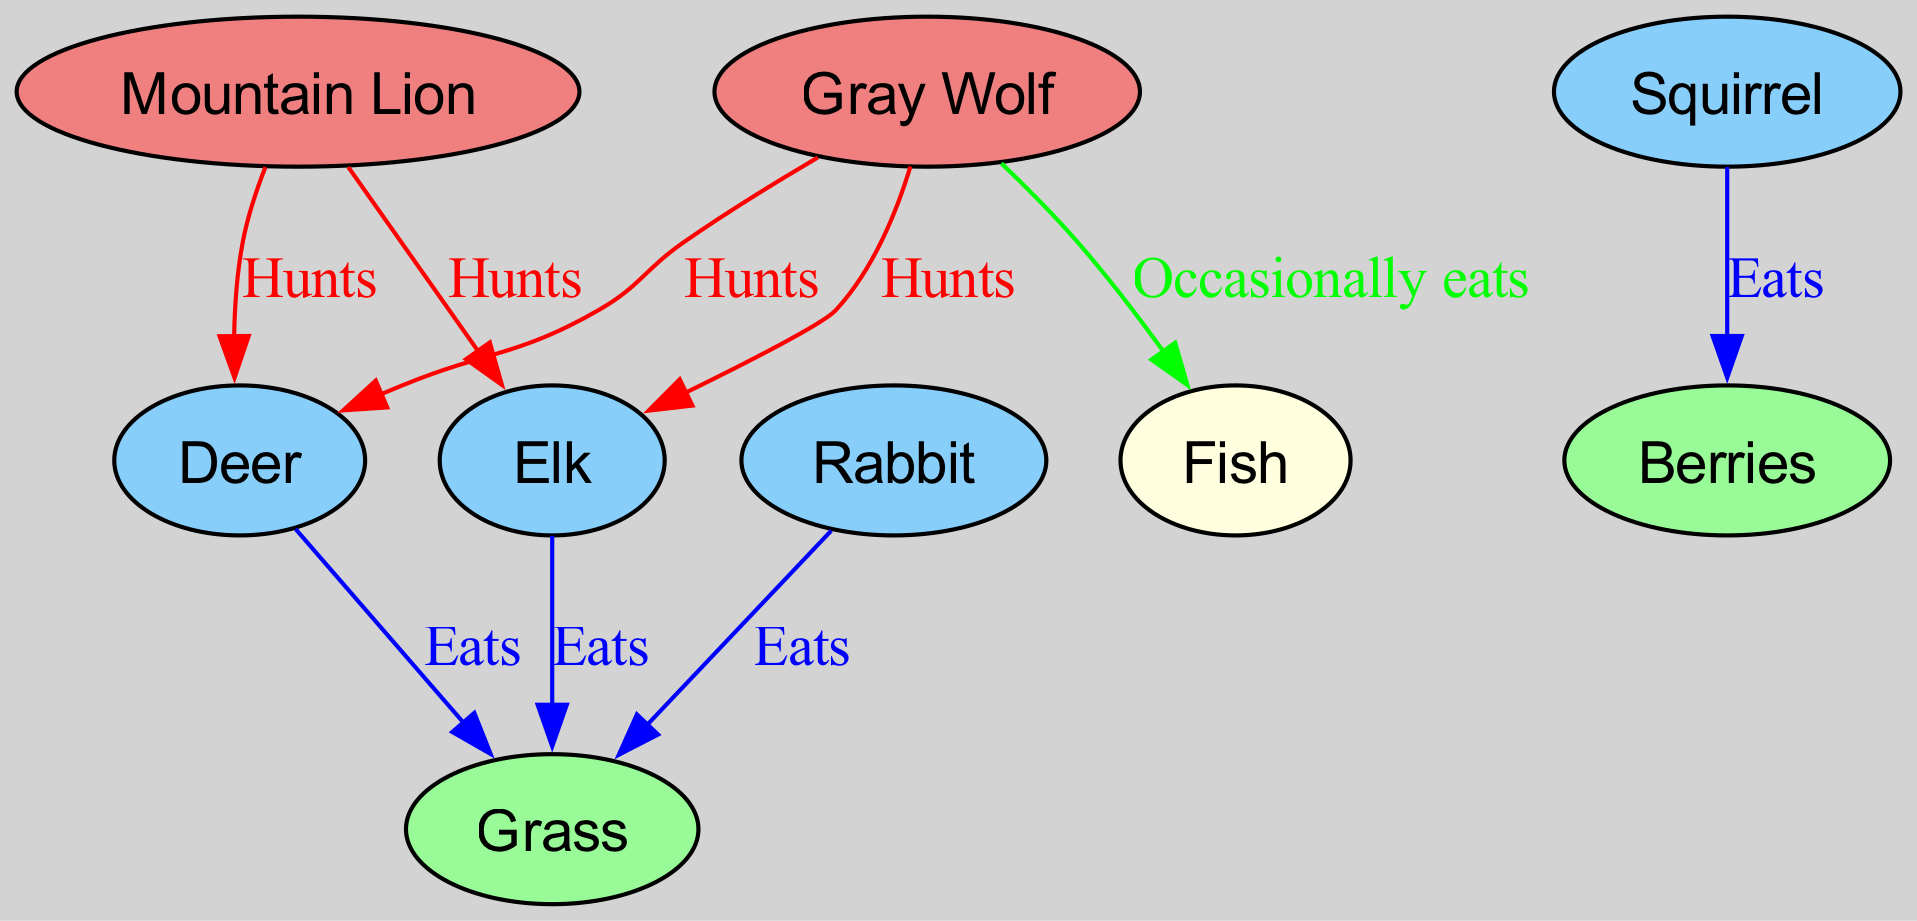What are the total number of nodes in the diagram? There are 9 distinct entities that represent either predators, prey, or plant life in the ecosystem, which are listed explicitly in the "nodes" section of the provided data.
Answer: 9 Which animal is hunted by both the Mountain Lion and the Gray Wolf? The diagram shows edges labeled "Hunts" indicating relationships where both predators target the same prey. Scanning through the edges, it is evident that both predators hunt the Deer.
Answer: Deer How many edges represent the "Eats" relationship? To determine this, I count all edges with the label "Eats" in the provided data. There are three edges corresponding to the "Eats" label.
Answer: 3 Which two animals are primarily herbivores in this ecosystem? By analyzing the nodes that have eat relationships with plants (Grass and Berries), I can determine the herbivores. The Deer and Elk eat Grass, while the Rabbit also eats Grass. Thus, Deer and Elk are identified as the primary herbivores.
Answer: Deer, Elk What is the color of the "Grass" node in the diagram? Each node is assigned a specific color according to the type of organism it represents. "Grass" is classified as a plant, which is colored pale green in the diagram's setup.
Answer: Pale green Which predator occasionally eats Fish according to the diagram? Reviewing all the edges labeled “Occasionally eats” reveals that the Gray Wolf has an edge directed towards Fish, which indicates that it occasionally consumes this prey.
Answer: Gray Wolf If Deer and Elk both eat Grass, how many predators hunt them? The diagram presents their relationships: Mountain Lions and Gray Wolves hunt both Deer and Elk. Therefore, counting unique predators for both leads to a total of two unique predators for them.
Answer: 2 Which animals do Squirrels primarily consume? The Squirrel node has an outgoing edge to the Berries node, which means it feeds on Berries as its primary food source.
Answer: Berries What kind of relationship do Mountain Lions have with Elk? The relationship between the Mountain Lion and Elk, labeled as "Hunts," represents a predatory interaction where the Mountain Lion hunts the Elk for food.
Answer: Hunts 